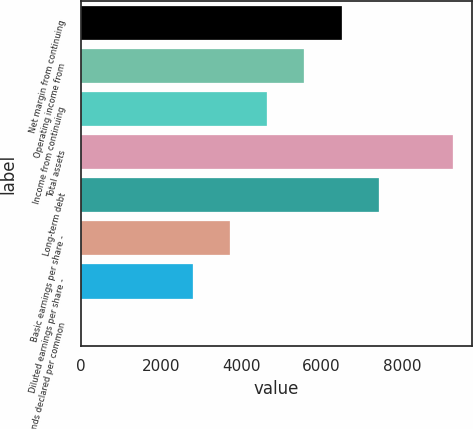<chart> <loc_0><loc_0><loc_500><loc_500><bar_chart><fcel>Net margin from continuing<fcel>Operating income from<fcel>Income from continuing<fcel>Total assets<fcel>Long-term debt<fcel>Basic earnings per share -<fcel>Diluted earnings per share -<fcel>Dividends declared per common<nl><fcel>6499.26<fcel>5570.95<fcel>4642.64<fcel>9284.2<fcel>7427.57<fcel>3714.33<fcel>2786.02<fcel>1.09<nl></chart> 